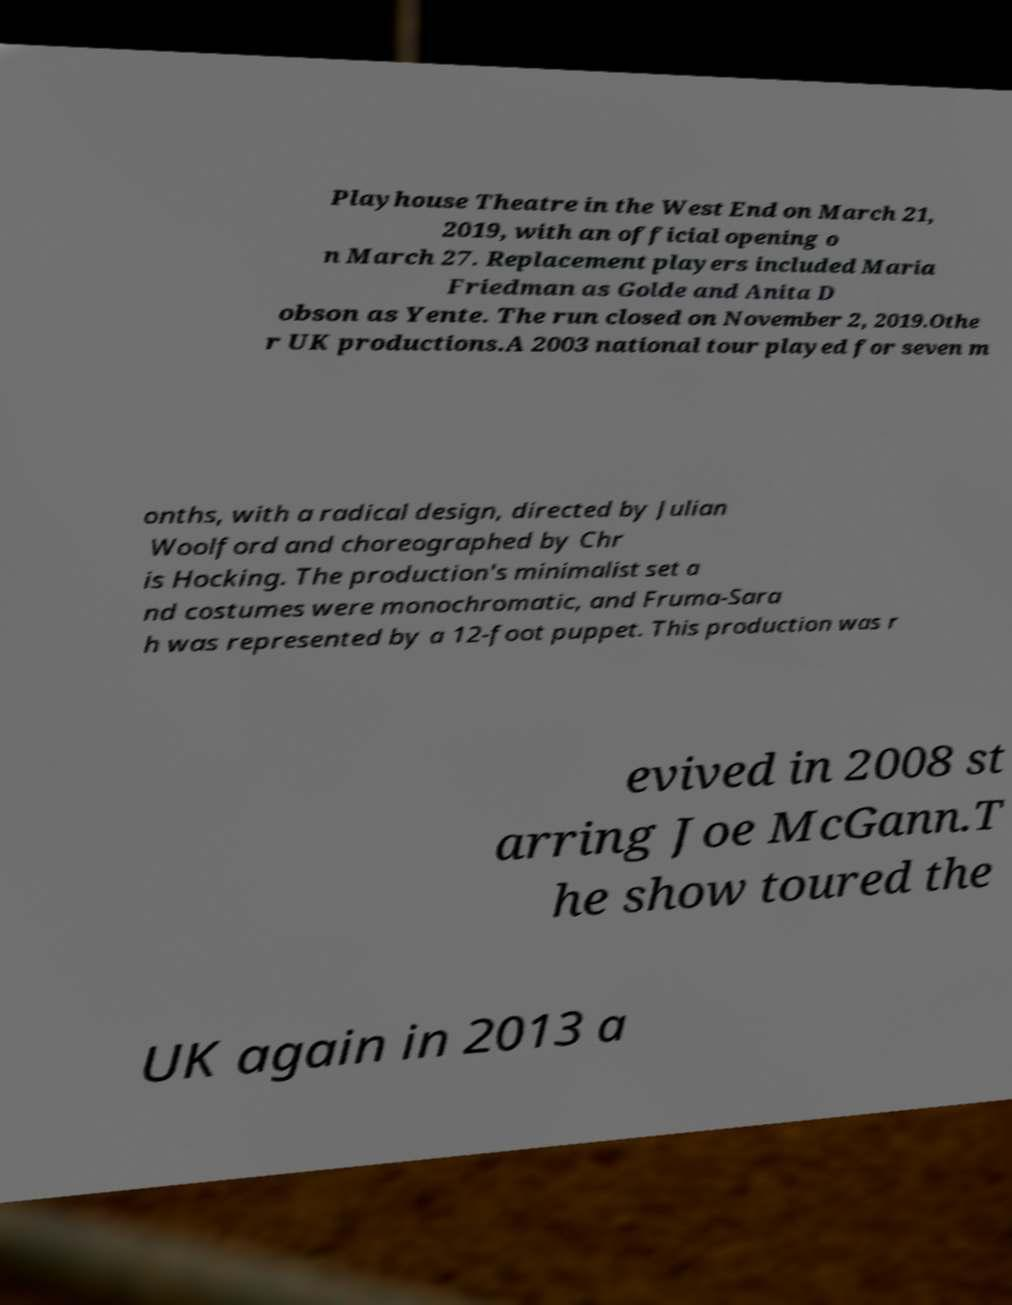Please read and relay the text visible in this image. What does it say? Playhouse Theatre in the West End on March 21, 2019, with an official opening o n March 27. Replacement players included Maria Friedman as Golde and Anita D obson as Yente. The run closed on November 2, 2019.Othe r UK productions.A 2003 national tour played for seven m onths, with a radical design, directed by Julian Woolford and choreographed by Chr is Hocking. The production's minimalist set a nd costumes were monochromatic, and Fruma-Sara h was represented by a 12-foot puppet. This production was r evived in 2008 st arring Joe McGann.T he show toured the UK again in 2013 a 